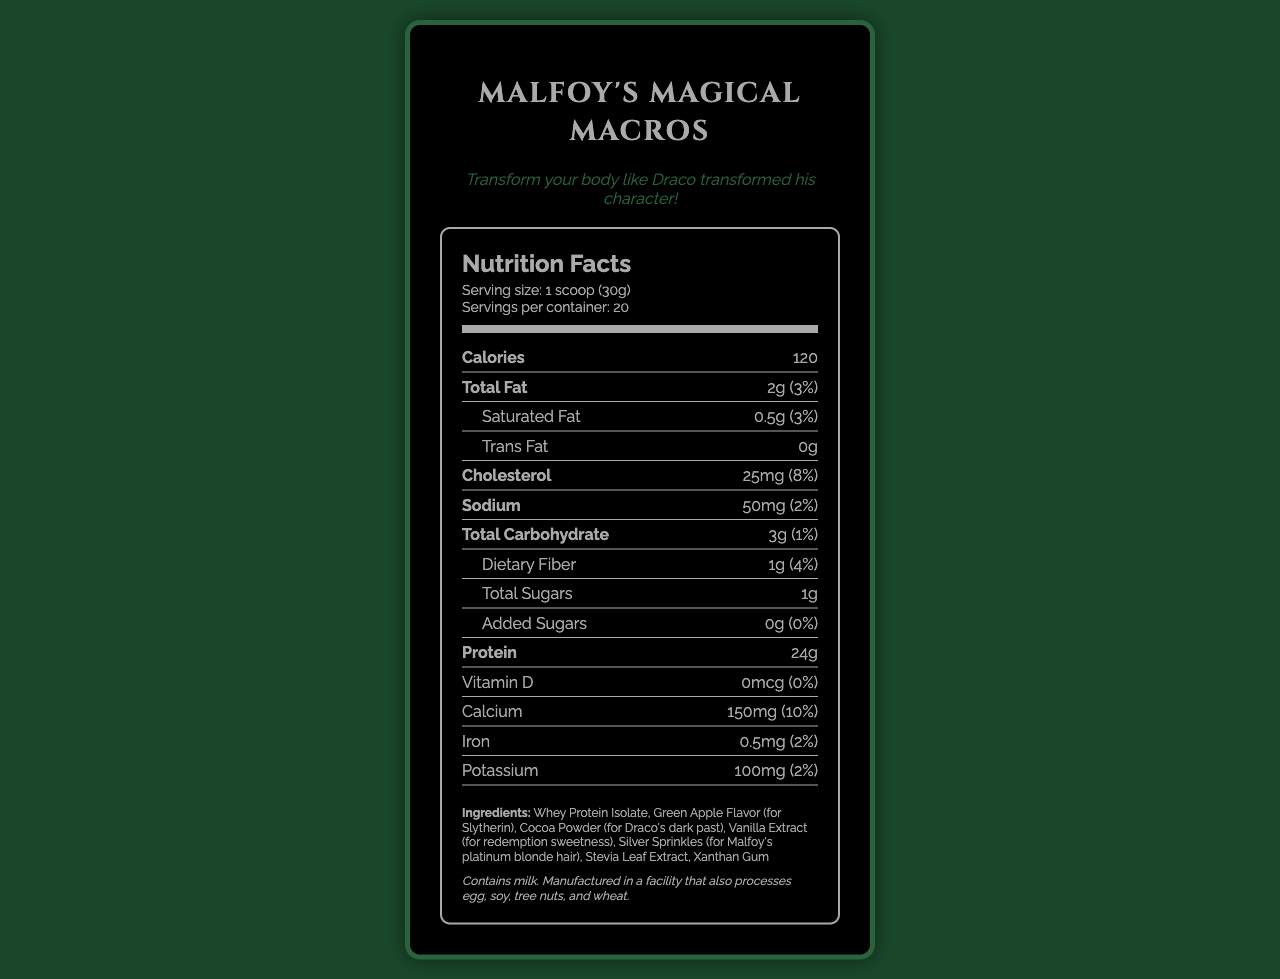what is the serving size of the "Redeeming Draco" themed protein shake? The document specifies the serving size as 1 scoop (30g).
Answer: 1 scoop (30g) how many servings are there per container? The document states that there are 20 servings per container.
Answer: 20 how many calories are in one serving? The document lists the calorie content per serving as 120 calories.
Answer: 120 how much protein is in one serving? The document indicates that each serving contains 24 grams of protein.
Answer: 24g what is the percentage daily value of total fat in one serving? The document shows that the daily value percentage for total fat in one serving is 3%.
Answer: 3% based on the document, which ingredient is used to signify Draco's dark past? A. Whey Protein Isolate B. Green Apple Flavor C. Cocoa Powder D. Vanilla Extract The ingredient "Cocoa Powder" is listed with the note "(for Draco's dark past)".
Answer: C. Cocoa Powder what is the nutrient amount of cholesterol per serving? A. 15mg B. 20mg C. 25mg D. 30mg The document lists the cholesterol amount per serving as 25mg.
Answer: C. 25mg how much calcium is in one serving and what percentage of the daily value does it provide? The document states that one serving contains 150mg of calcium, which is 10% of the daily value.
Answer: 150mg (10%) is the "Redeeming Draco" themed protein shake suitable for individuals with milk allergies? The document states that the product contains milk and is manufactured in a facility that also processes egg, soy, tree nuts, and wheat.
Answer: No summarize the main components and theme of the "Redeeming Draco" themed protein shake document. The main components of the document include nutritional information, ingredients, allergen information, and the thematic branding related to Draco Malfoy's character transformation.
Answer: The document provides the nutrition facts for "Malfoy's Magical Macros" Slytherin Redemption Apple protein shake. It highlights the serving size, calorie content, macronutrients, vitamins, and minerals. The shake contains 24g of protein and 120 calories per serving. The ingredients include some thematic elements such as green apple flavor for Slytherin and cocoa powder for Draco's dark past. It is not suitable for people with milk allergies. how much total carbohydrate is in one serving? The document shows that there are 3 grams of total carbohydrate in one serving.
Answer: 3g what is the brand name of the "Redeeming Draco" themed protein shake? The document lists the brand name as "Malfoy's Magical Macros".
Answer: Malfoy's Magical Macros how many grams of dietary fiber does one serving contain? The document states that one serving contains 1 gram of dietary fiber.
Answer: 1g how does the shake's theme relate to Draco Malfoy? The document notes the thematic ingredients and the branding centered around Draco's transformation.
Answer: The shake incorporates elements reflecting Draco Malfoy's transformation and character traits, such as green apple for Slytherin, cocoa powder for his dark past, and vanilla extract for the sweetness of redemption. what is the daily value percentage of iron per serving? The document mentions that the daily value percentage of iron per serving is 2%.
Answer: 2% is the amount of vitamin D in the protein shake significant? The document states that the amount of vitamin D is 0 mcg, which is insignificant.
Answer: No what is the tagline of the "Malfoy's Magical Macros" brand? The document includes the tagline “Transform your body like Draco transformed his character!”
Answer: Transform your body like Draco transformed his character! how long will 1 container last if you have 2 servings per day? Since the container has 20 servings, consuming 2 servings per day would make the container last for 10 days.
Answer: 10 days how does the serving size of this protein shake compare to other common protein shakes? The document does not provide information regarding the serving sizes of other protein shakes, so a comparison cannot be made.
Answer: Cannot be determined 